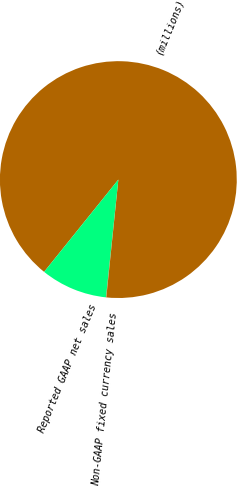Convert chart. <chart><loc_0><loc_0><loc_500><loc_500><pie_chart><fcel>(millions)<fcel>Reported GAAP net sales<fcel>Non-GAAP fixed currency sales<nl><fcel>90.83%<fcel>9.12%<fcel>0.04%<nl></chart> 